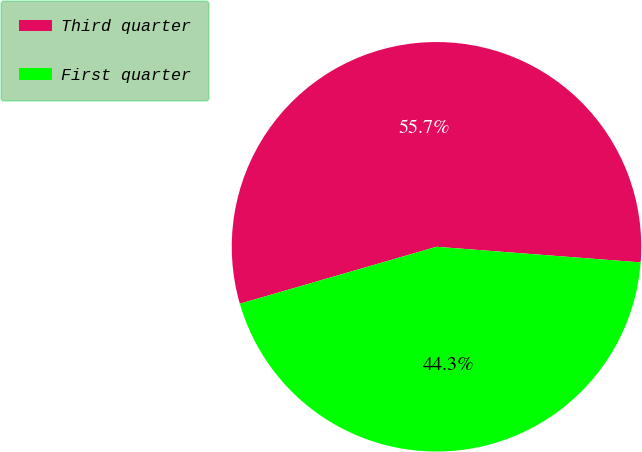Convert chart to OTSL. <chart><loc_0><loc_0><loc_500><loc_500><pie_chart><fcel>Third quarter<fcel>First quarter<nl><fcel>55.7%<fcel>44.3%<nl></chart> 